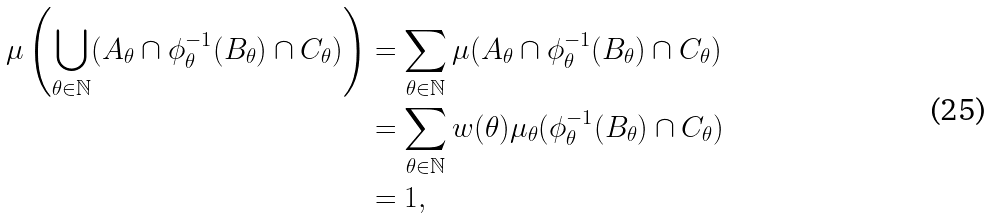Convert formula to latex. <formula><loc_0><loc_0><loc_500><loc_500>\mu \left ( \bigcup _ { \theta \in \mathbb { N } } ( A _ { \theta } \cap \phi _ { \theta } ^ { - 1 } ( B _ { \theta } ) \cap C _ { \theta } ) \right ) & = \sum _ { \theta \in \mathbb { N } } \mu ( A _ { \theta } \cap \phi _ { \theta } ^ { - 1 } ( B _ { \theta } ) \cap C _ { \theta } ) \\ & = \sum _ { \theta \in \mathbb { N } } w ( \theta ) \mu _ { \theta } ( \phi _ { \theta } ^ { - 1 } ( B _ { \theta } ) \cap C _ { \theta } ) \\ & = 1 ,</formula> 